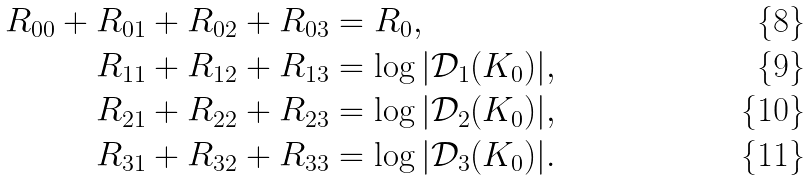<formula> <loc_0><loc_0><loc_500><loc_500>R _ { 0 0 } + R _ { 0 1 } + R _ { 0 2 } + R _ { 0 3 } & = R _ { 0 } , \\ R _ { 1 1 } + R _ { 1 2 } + R _ { 1 3 } & = \log | \mathcal { D } _ { 1 } ( K _ { 0 } ) | , \\ R _ { 2 1 } + R _ { 2 2 } + R _ { 2 3 } & = \log | \mathcal { D } _ { 2 } ( K _ { 0 } ) | , \\ R _ { 3 1 } + R _ { 3 2 } + R _ { 3 3 } & = \log | \mathcal { D } _ { 3 } ( K _ { 0 } ) | .</formula> 